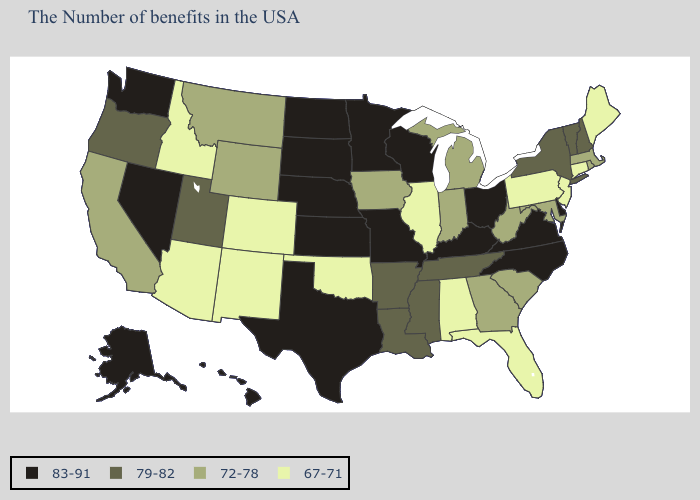What is the lowest value in states that border Massachusetts?
Write a very short answer. 67-71. What is the highest value in states that border Minnesota?
Quick response, please. 83-91. Which states have the lowest value in the USA?
Give a very brief answer. Maine, Connecticut, New Jersey, Pennsylvania, Florida, Alabama, Illinois, Oklahoma, Colorado, New Mexico, Arizona, Idaho. Which states hav the highest value in the MidWest?
Keep it brief. Ohio, Wisconsin, Missouri, Minnesota, Kansas, Nebraska, South Dakota, North Dakota. Name the states that have a value in the range 79-82?
Concise answer only. New Hampshire, Vermont, New York, Tennessee, Mississippi, Louisiana, Arkansas, Utah, Oregon. What is the value of Nebraska?
Write a very short answer. 83-91. What is the lowest value in the USA?
Keep it brief. 67-71. What is the value of Washington?
Short answer required. 83-91. How many symbols are there in the legend?
Be succinct. 4. What is the lowest value in the West?
Quick response, please. 67-71. Is the legend a continuous bar?
Keep it brief. No. Does Nebraska have the same value as Colorado?
Short answer required. No. Among the states that border Ohio , which have the highest value?
Be succinct. Kentucky. What is the highest value in states that border Vermont?
Concise answer only. 79-82. What is the lowest value in the USA?
Short answer required. 67-71. 